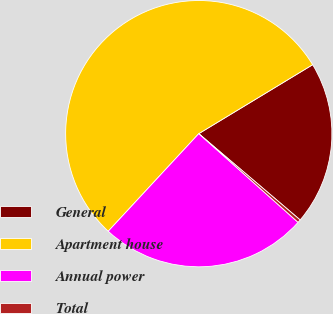Convert chart to OTSL. <chart><loc_0><loc_0><loc_500><loc_500><pie_chart><fcel>General<fcel>Apartment house<fcel>Annual power<fcel>Total<nl><fcel>19.89%<fcel>54.43%<fcel>25.3%<fcel>0.38%<nl></chart> 